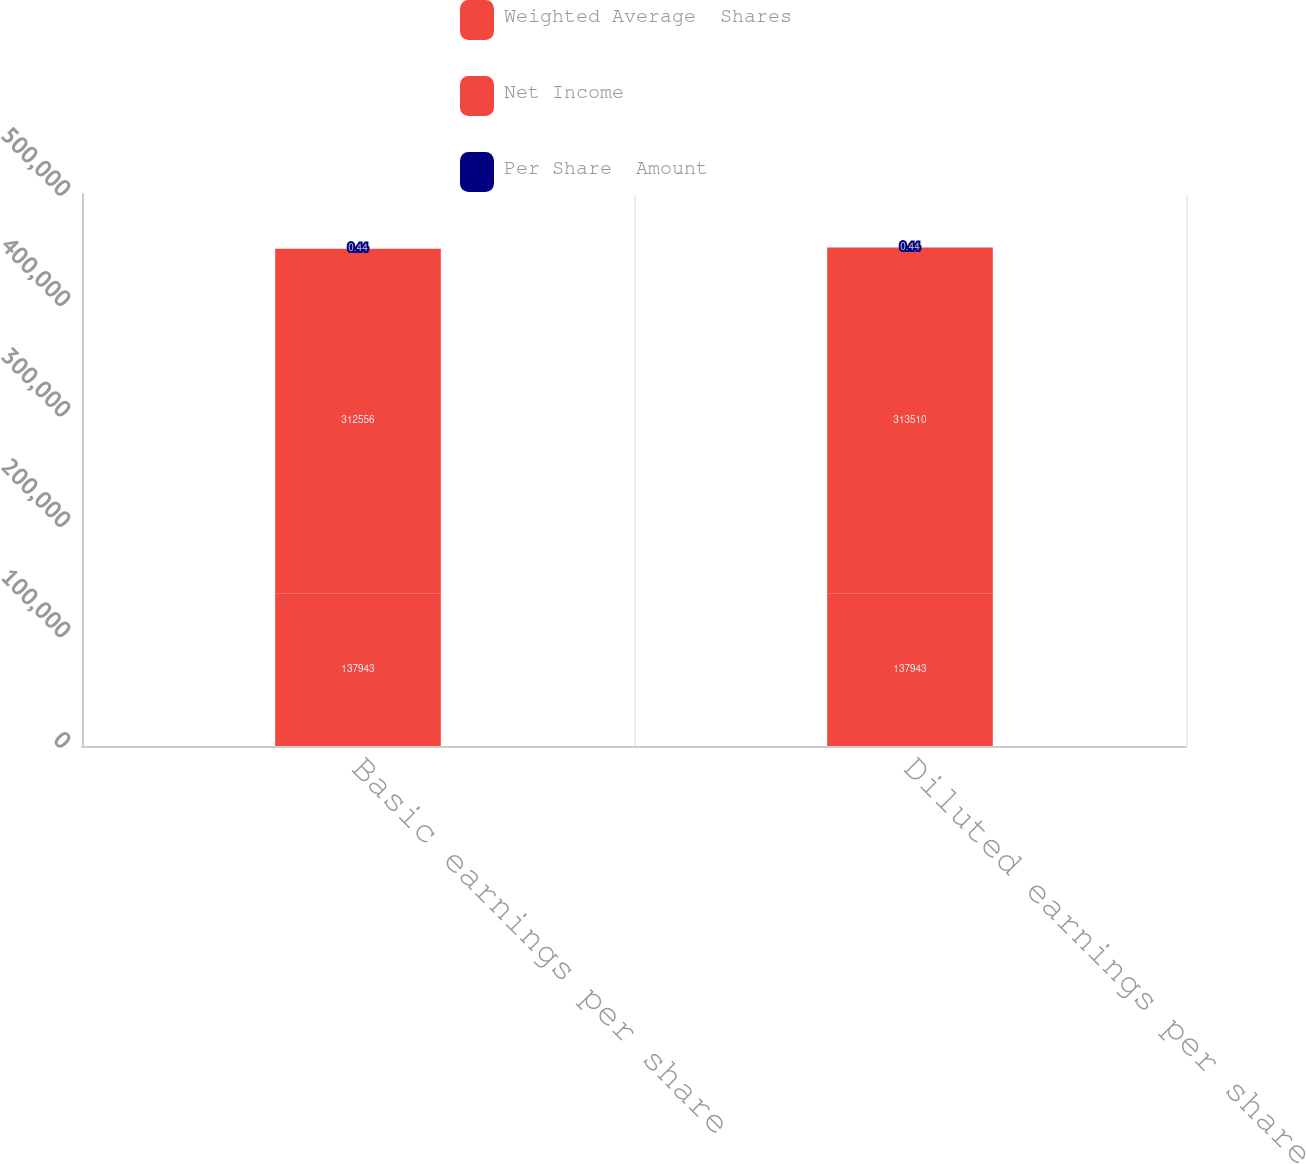<chart> <loc_0><loc_0><loc_500><loc_500><stacked_bar_chart><ecel><fcel>Basic earnings per share<fcel>Diluted earnings per share<nl><fcel>Weighted Average  Shares<fcel>137943<fcel>137943<nl><fcel>Net Income<fcel>312556<fcel>313510<nl><fcel>Per Share  Amount<fcel>0.44<fcel>0.44<nl></chart> 